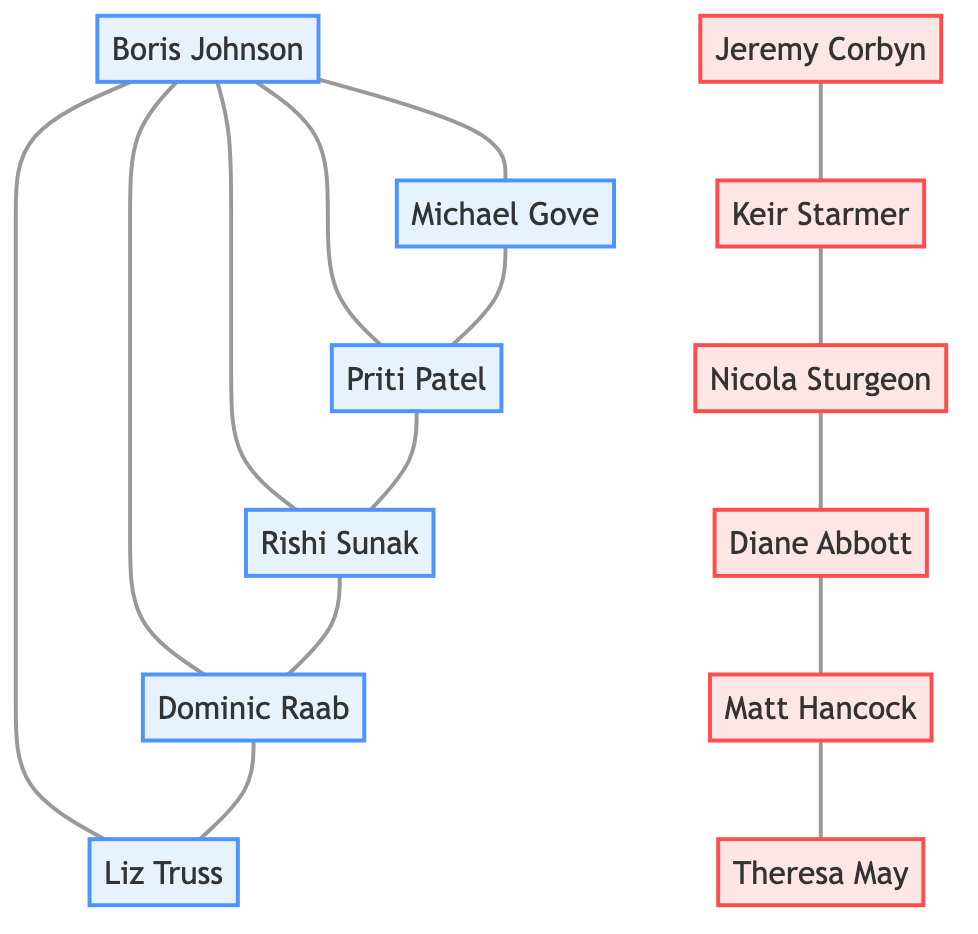What is the total number of trusted politicians in the diagram? The diagram includes nodes labeled as "trusted." By counting these nodes (Boris Johnson, Michael Gove, Priti Patel, Rishi Sunak, Dominic Raab, Liz Truss), we find that there are a total of six trusted politicians.
Answer: 6 How many politicians are distrusted according to the diagram? To find the total number of distrusted politicians, I count the nodes labeled as "distrusted." The list includes Jeremy Corbyn, Keir Starmer, Nicola Sturgeon, Diane Abbott, Matt Hancock, and Theresa May, resulting in a total of six distrusted politicians.
Answer: 6 Which politician is trusted and connected to both Rishi Sunak and Liz Truss? I look for a trusted politician that shares edges with both Rishi Sunak and Liz Truss. The connections show that Dominic Raab is linked to Rishi Sunak and also has a direct connection to Liz Truss, indicating that he is the one who fits this criterion.
Answer: Dominic Raab Is there a direct connection between Boris Johnson and Theresa May? I examine the links in the diagram specifically looking for a direct connection between Boris Johnson and Theresa May. There is no edge or link connecting these two nodes directly, meaning no direct connection exists between them.
Answer: No Which trusted politician is indirectly connected to Jeremy Corbyn? To find this, I trace the connections from Jeremy Corbyn through the distrusted nodes. Jeremy Corbyn connects to Keir Starmer, who connects to Nicola Sturgeon, followed by connections to Diane Abbott, who eventually connects to Matt Hancock, and then Theresa May. I then check the trusted politicians and find that while there is no direct line, the trusted politician nearby is Boris Johnson through multiple steps, confirming indirect connection exists.
Answer: Boris Johnson What type of relationships exist between trusted politicians only? By looking at the connections only between trusted politicians, I see that they are exclusively connected to one another without any distrustful nodes interjecting; this highlights pretty positive interrelations among trusted politicians.
Answer: Only trusted relationships Count the number of edges connected to Michael Gove. I locate Michael Gove in the diagram and evaluate the edges connecting him. The connections are with Boris Johnson and Priti Patel, indicating a total of 2 edges linked to Michael Gove.
Answer: 2 Who is the most connected trusted politician? I review the connections for each trusted politician to determine who has the most links. Boris Johnson is connected to Michael Gove, Priti Patel, Rishi Sunak, Dominic Raab, and Liz Truss, giving him the highest number of connections, with a total of 5.
Answer: Boris Johnson What is the relationship between Keir Starmer and Nicola Sturgeon? Referring to the diagram, there is a direct link between Keir Starmer and Nicola Sturgeon, indicating that they are directly connected to each other, which represents a relationship characterized as distrustful.
Answer: Directly connected 